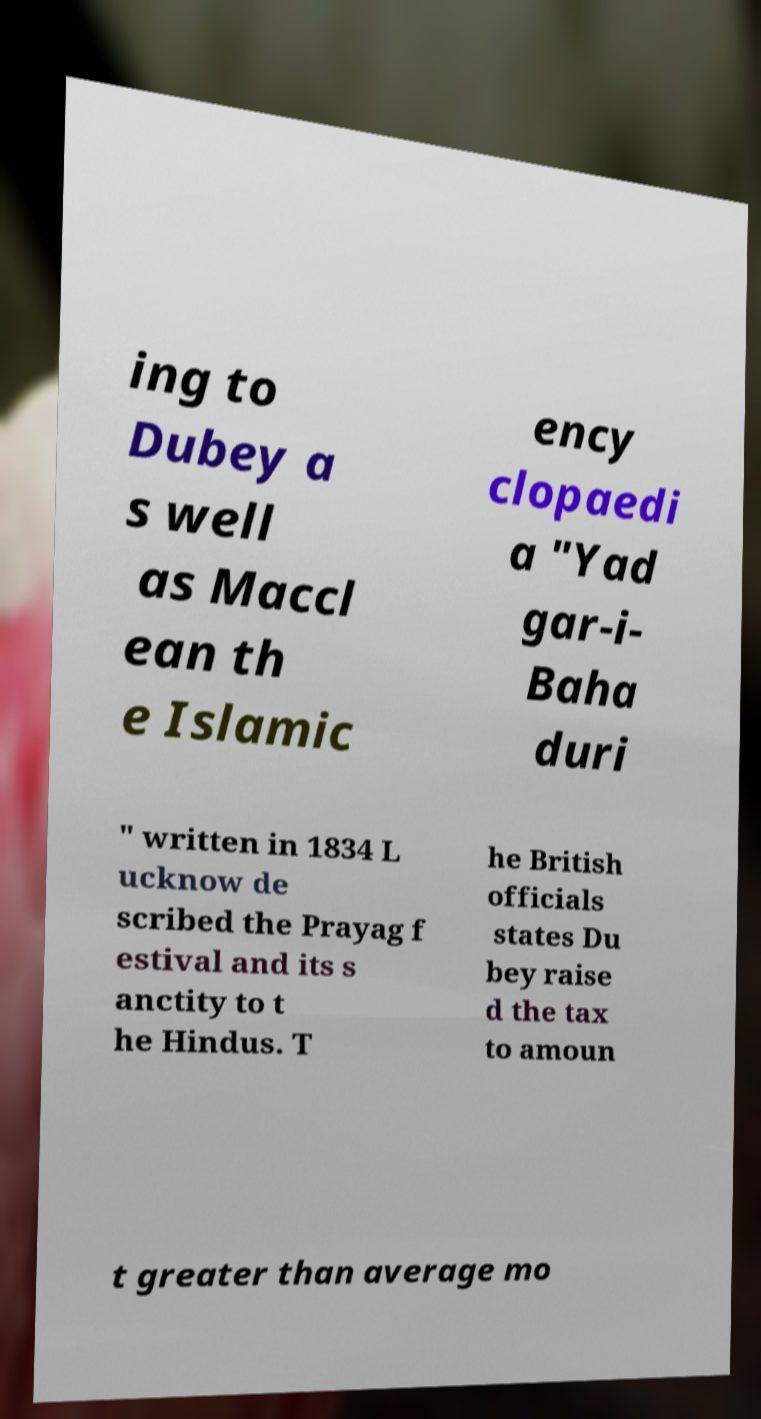Can you read and provide the text displayed in the image?This photo seems to have some interesting text. Can you extract and type it out for me? ing to Dubey a s well as Maccl ean th e Islamic ency clopaedi a "Yad gar-i- Baha duri " written in 1834 L ucknow de scribed the Prayag f estival and its s anctity to t he Hindus. T he British officials states Du bey raise d the tax to amoun t greater than average mo 